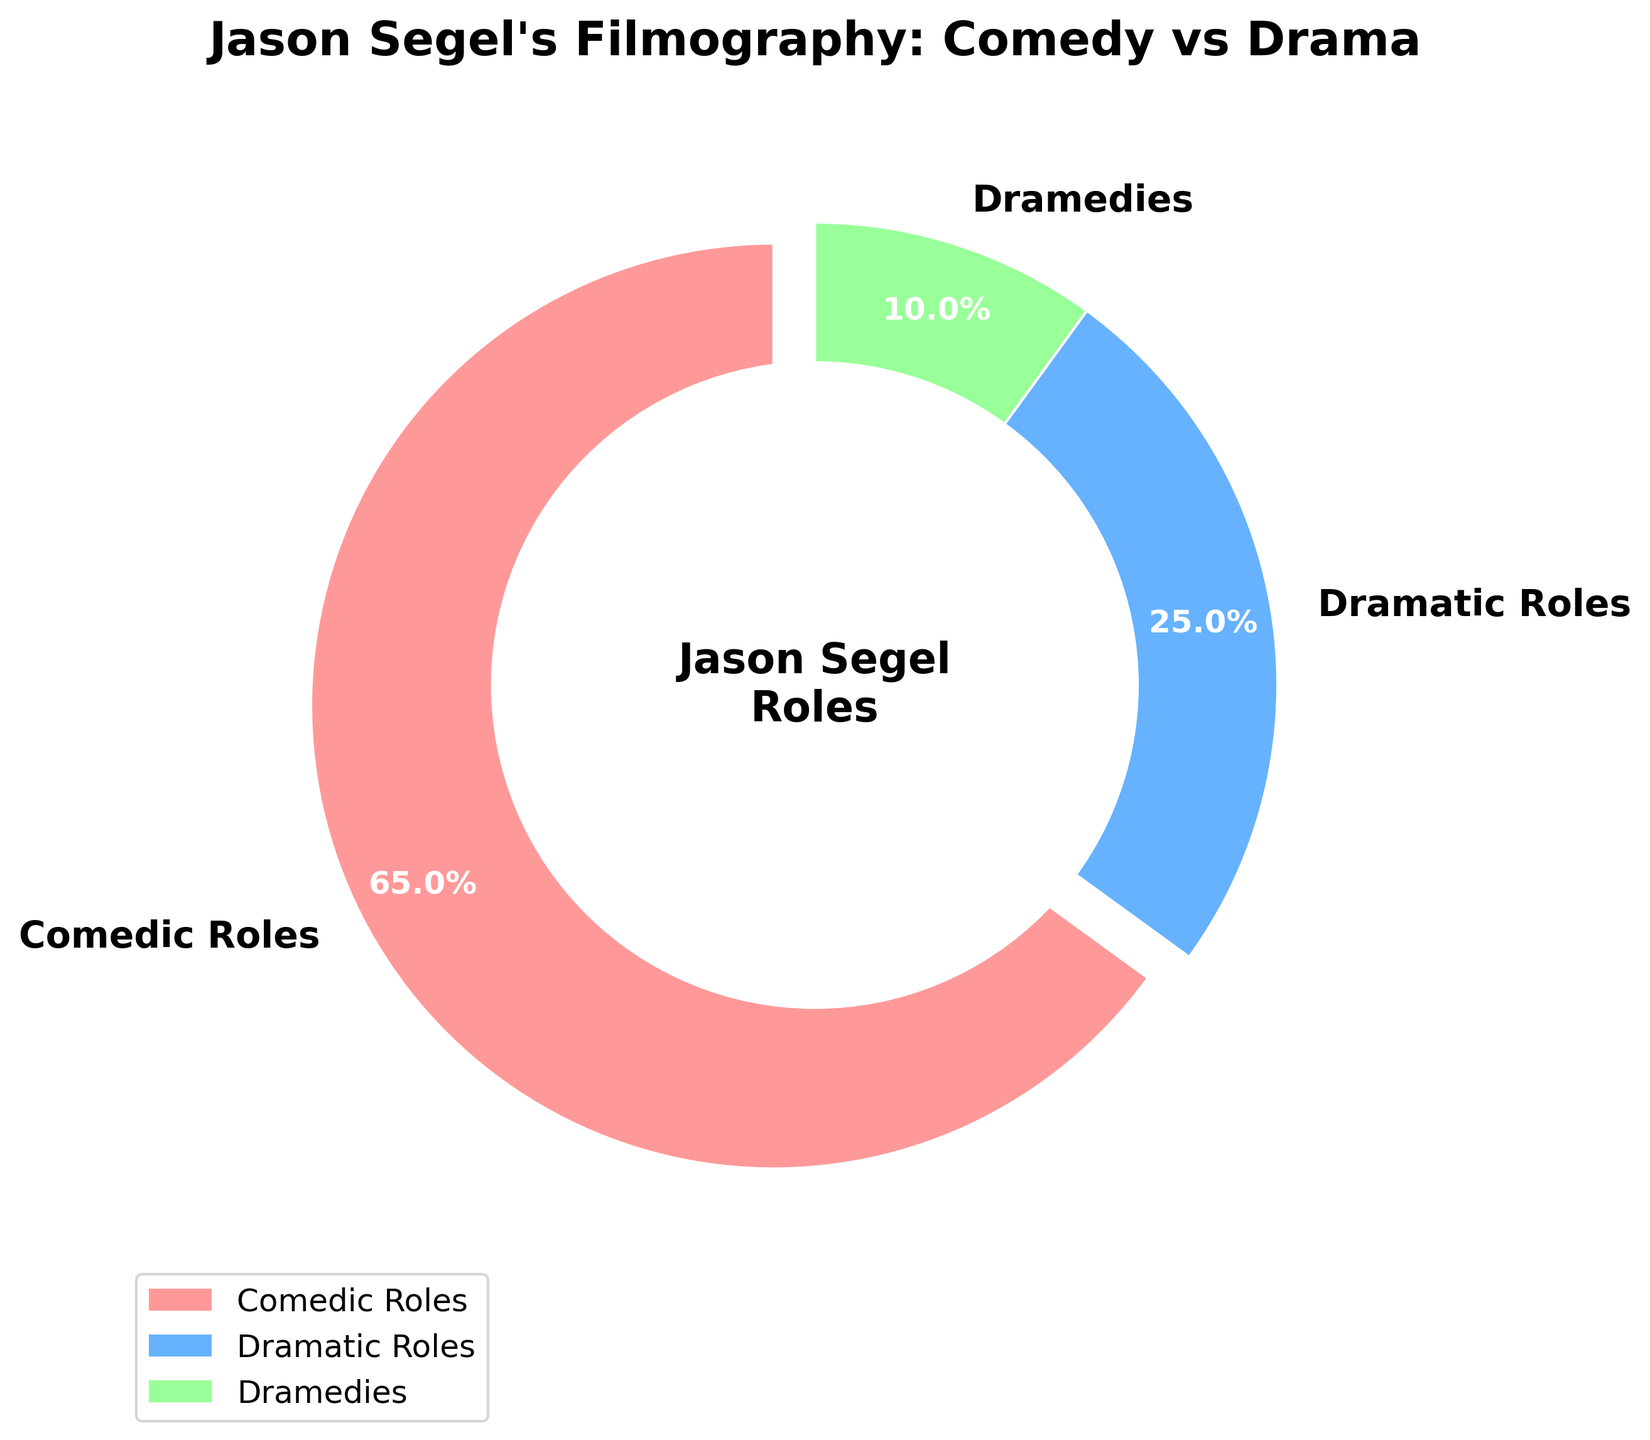What percentage of Jason Segel's roles are comedies? Refer to the "Comedic Roles" segment of the pie chart, which is labeled as 65%.
Answer: 65% How do the proportions of dramatic roles and dramedy roles compare? Look at the "Dramatic Roles" and "Dramedies" segments. Dramatic roles are 25%, and dramedies are 10%, so dramatic roles are more frequent than dramedy roles.
Answer: Dramatic roles are more frequent What is the combined percentage of roles that are either comedic or dramedies? Sum the percentages of "Comedic Roles" and "Dramedies": 65% + 10% = 75%.
Answer: 75% Which type of roles is the least common in Jason Segel's filmography? Identify the segment with the smallest percentage, which is "Dramedies" at 10%.
Answer: Dramedies What is the difference in percentage between comedic and dramatic roles? Subtract the percentage of "Dramatic Roles" from "Comedic Roles": 65% - 25% = 40%.
Answer: 40% What color represents dramatic roles in the pie chart? Look at the segment labeled "Dramatic Roles," which is colored blue.
Answer: Blue Which type of role has a segment that is slightly separated from the rest of the pie? Identify the segment with an explode effect, which is "Comedic Roles".
Answer: Comedic Roles If Jason Segel adds 3 more films to his dramatic roles, how might this impact the pie chart? Adding roles would increase the percentage of dramatic roles and decrease the proportions of the others (assuming the total number of roles changes). However, specific calculations are needed to determine the exact impact.
Answer: Increase dramatic role percentage What is the ratio of comedic roles to dramatic roles? Divide the percentage of "Comedic Roles" by "Dramatic Roles": 65% / 25% = 2.6.
Answer: 2.6 